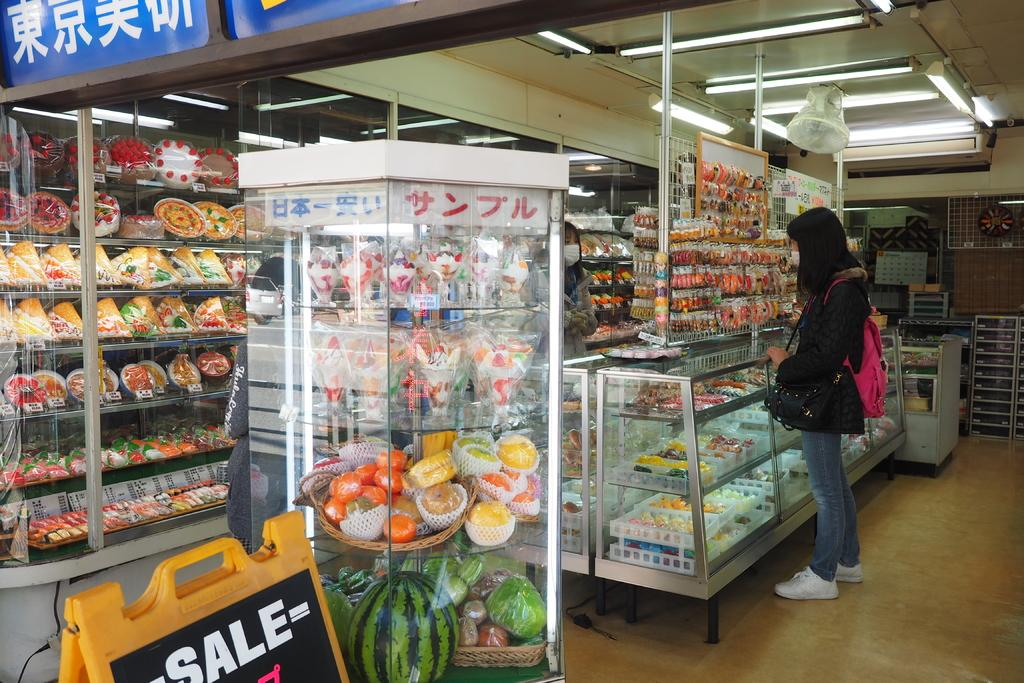<image>
Render a clear and concise summary of the photo. Some items in this store are on sale. 